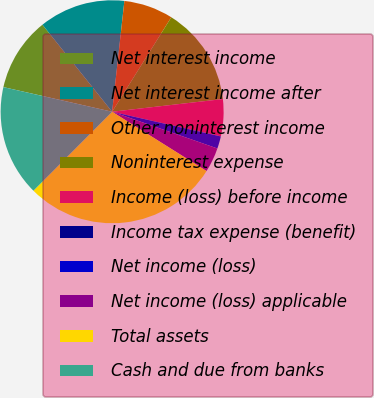Convert chart to OTSL. <chart><loc_0><loc_0><loc_500><loc_500><pie_chart><fcel>Net interest income<fcel>Net interest income after<fcel>Other noninterest income<fcel>Noninterest expense<fcel>Income (loss) before income<fcel>Income tax expense (benefit)<fcel>Net income (loss)<fcel>Net income (loss) applicable<fcel>Total assets<fcel>Cash and due from banks<nl><fcel>10.71%<fcel>12.5%<fcel>7.15%<fcel>14.28%<fcel>5.36%<fcel>0.01%<fcel>1.79%<fcel>3.58%<fcel>28.55%<fcel>16.07%<nl></chart> 